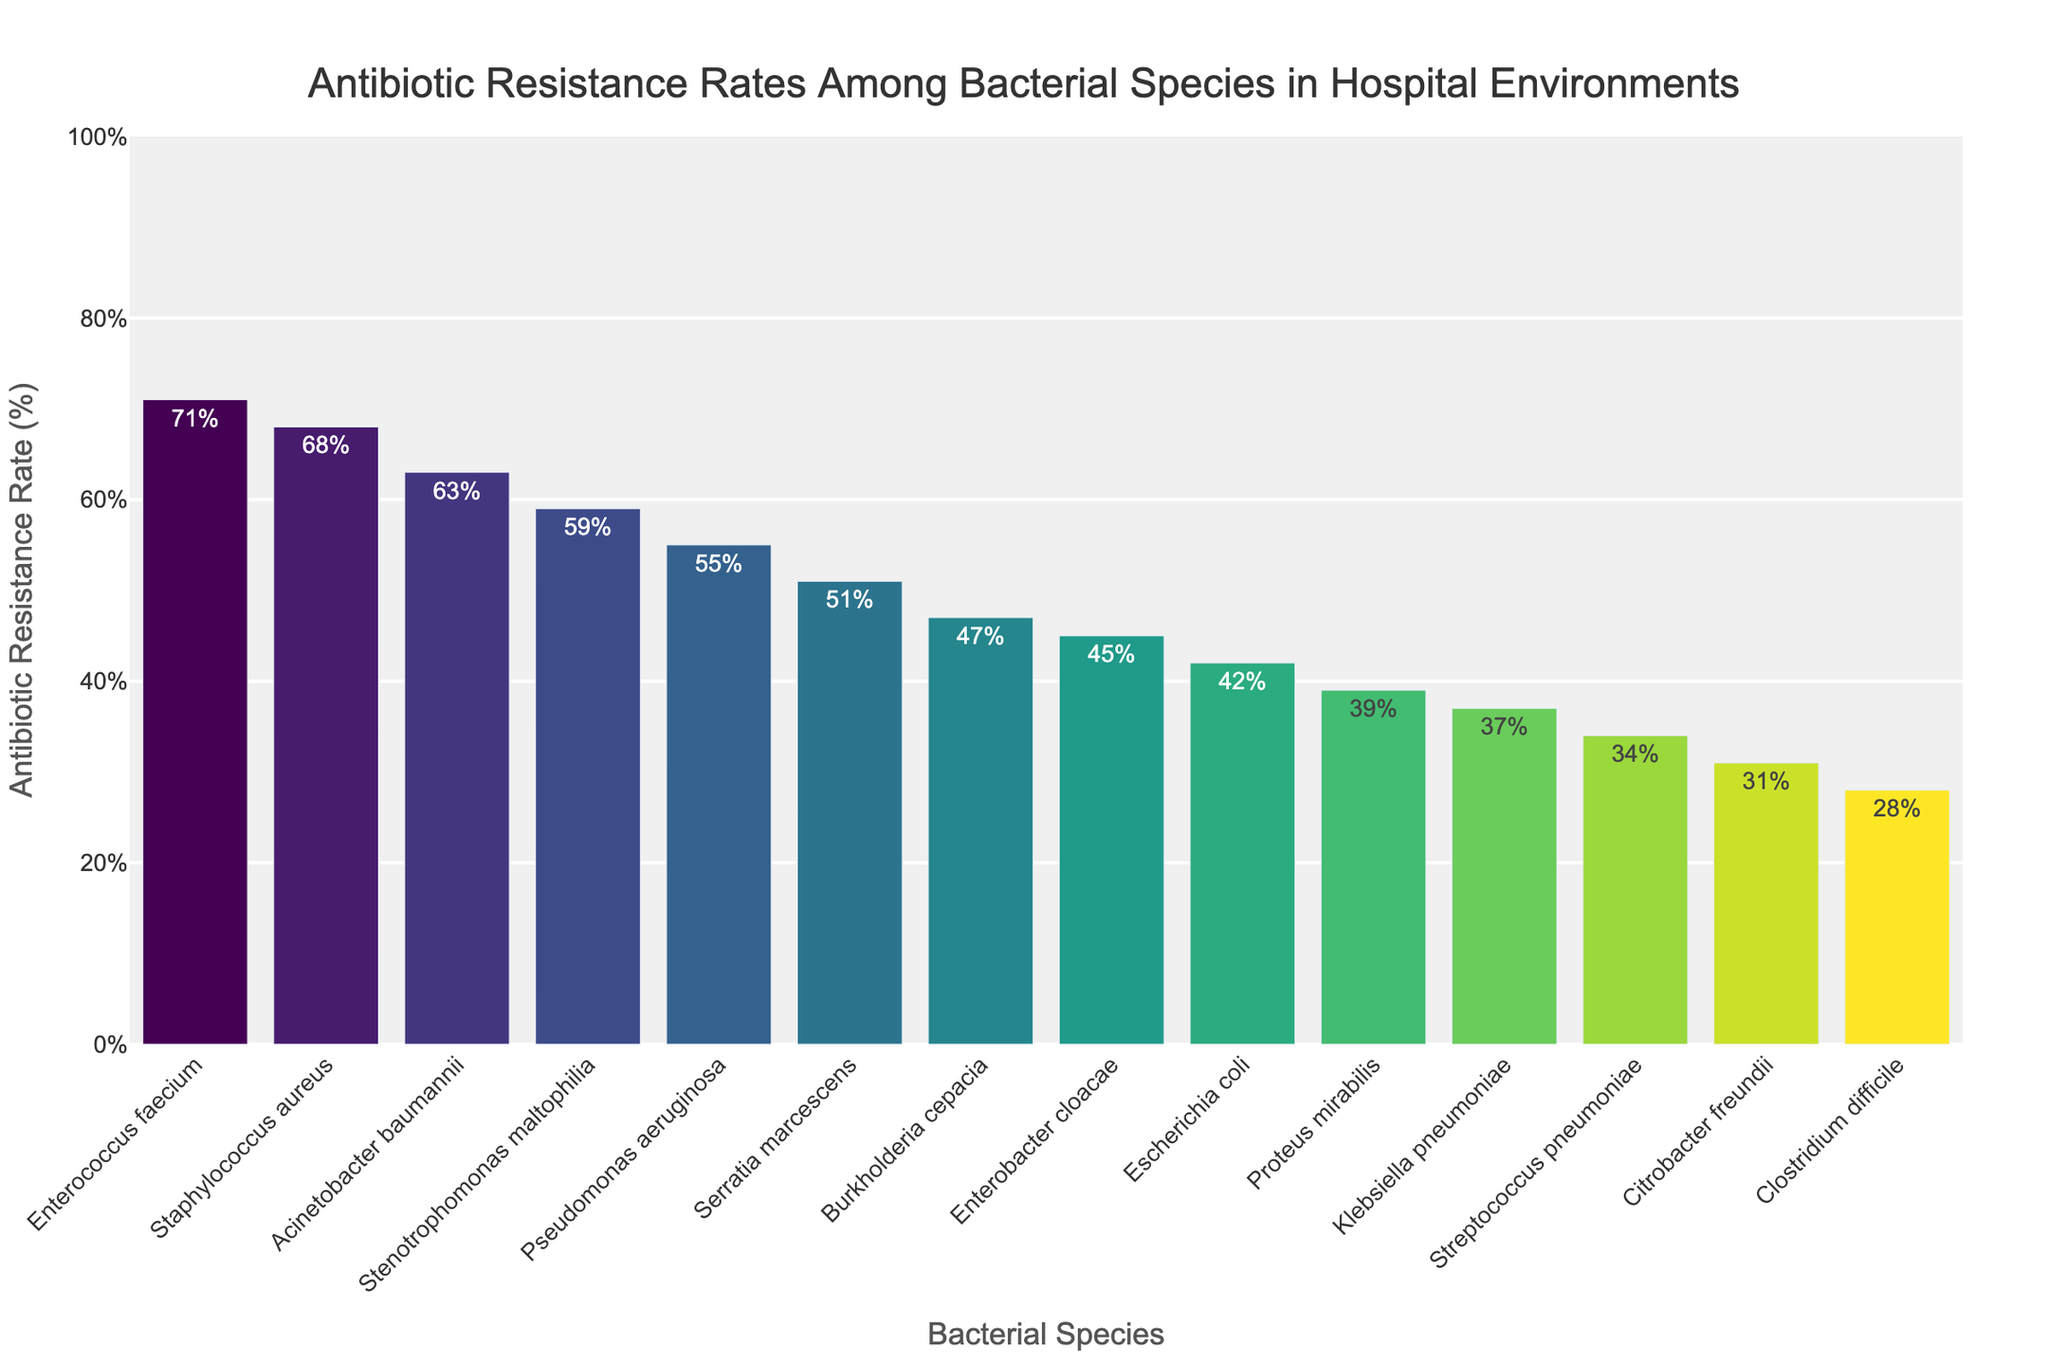Which bacterial species has the highest antibiotic resistance rate? To determine which bacterial species has the highest antibiotic resistance rate, look for the longest bar in the bar chart. This bar corresponds to Enterococcus faecium with a resistance rate of 71%.
Answer: Enterococcus faecium What is the difference in antibiotic resistance rates between Staphylococcus aureus and Escherichia coli? To find the difference, subtract the resistance rate of Escherichia coli (42%) from that of Staphylococcus aureus (68%). So, 68% - 42% = 26%.
Answer: 26% Which bacterial species has a lower antibiotic resistance rate, Klebsiella pneumoniae or Serratia marcescens? Compare the heights of the bars corresponding to Klebsiella pneumoniae (37%) and Serratia marcescens (51%). Klebsiella pneumoniae has a lower resistance rate.
Answer: Klebsiella pneumoniae What is the average antibiotic resistance rate of the bacterial species shown in the chart? Sum all the resistance rates and divide by the number of bacterial species. The resistance rates are: 68 + 42 + 55 + 37 + 71 + 63 + 28 + 34 + 45 + 39 + 51 + 59 + 31 + 47. The sum is 670, and there are 14 species. So, 670 / 14 ≈ 47.9%.
Answer: 47.9% What are the antibiotic resistance rates for species with resistance rates above 50%? List the species with resistance rates above 50% from the bar chart: Staphylococcus aureus (68%), Pseudomonas aeruginosa (55%), Enterococcus faecium (71%), Acinetobacter baumannii (63%), Stenotrophomonas maltophilia (59%), and Serratia marcescens (51%).
Answer: 68%, 55%, 71%, 63%, 59%, 51% Is Citrobacter freundii's antibiotic resistance rate above or below the average rate of all species? Calculate the average rate (47.9%) and compare it with Citrobacter freundii's rate (31%). Citrobacter freundii's rate is below the average.
Answer: Below What is the median antibiotic resistance rate of all the bacterial species? To find the median, list all antibiotic resistance rates in ascending order: 28, 31, 34, 37, 39, 42, 45, 47, 51, 55, 59, 63, 68, 71. Since there is an even number of species (14), the median is the average of the 7th and 8th values: (45 + 47) / 2 = 46%.
Answer: 46% How many bacterial species have an antibiotic resistance rate between 30% and 50%? Count the bars representing species with resistance rates between 30% and 50%: Escherichia coli (42%), Klebsiella pneumoniae (37%), Streptococcus pneumoniae (34%), Enterobacter cloacae (45%), Proteus mirabilis (39%), Citrobacter freundii (31%), and Burkholderia cepacia (47%). There are 7 species in this range.
Answer: 7 Which bacterial species has the closest antibiotic resistance rate to the median rate? Referring to the median rate of 46%, Burkholderia cepacia has the closest antibiotic resistance rate with 47%.
Answer: Burkholderia cepacia 